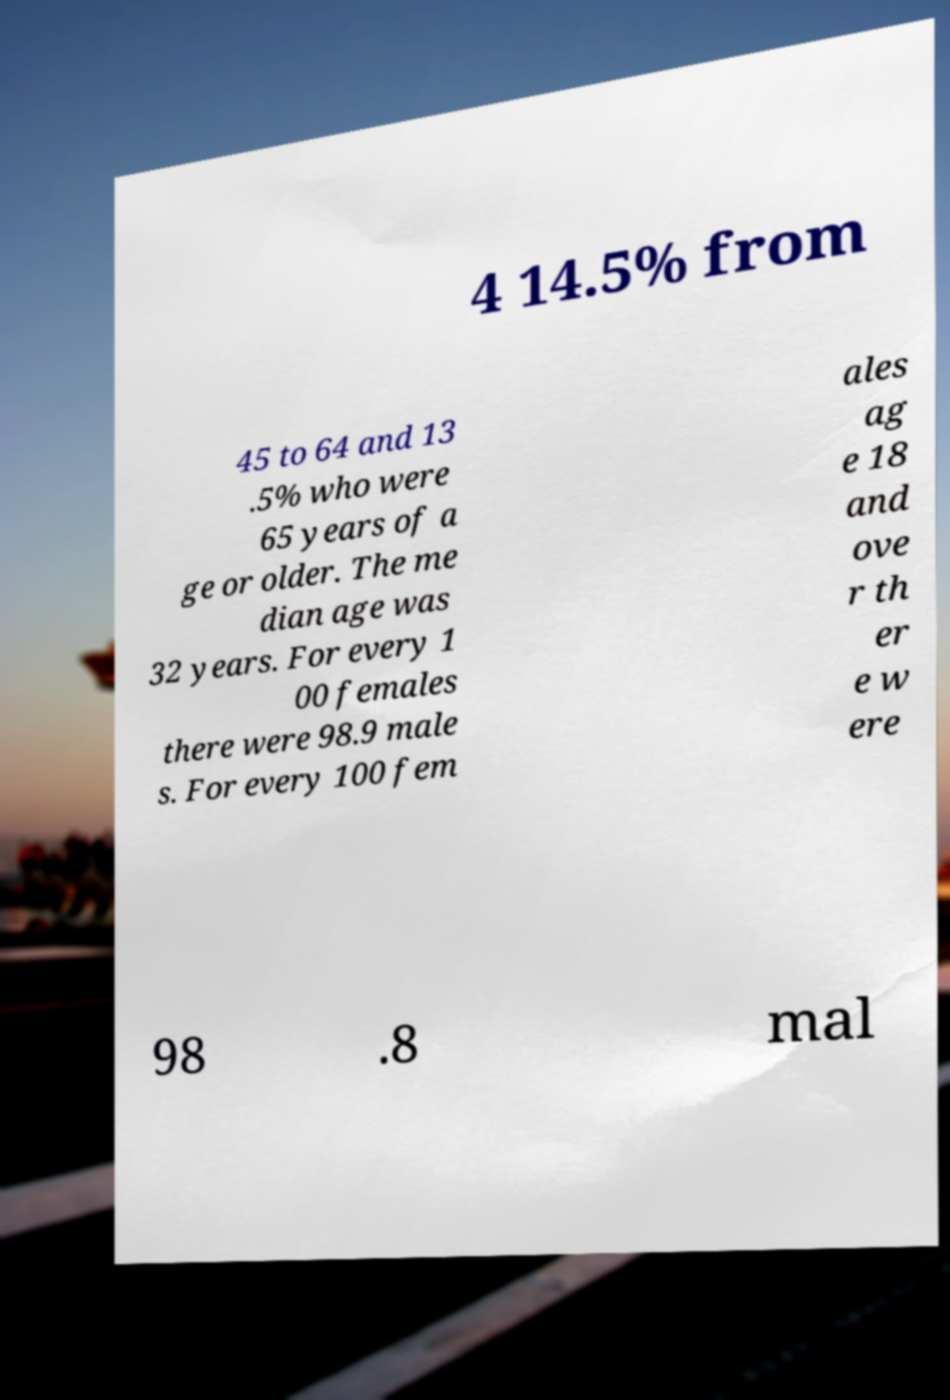Can you accurately transcribe the text from the provided image for me? 4 14.5% from 45 to 64 and 13 .5% who were 65 years of a ge or older. The me dian age was 32 years. For every 1 00 females there were 98.9 male s. For every 100 fem ales ag e 18 and ove r th er e w ere 98 .8 mal 